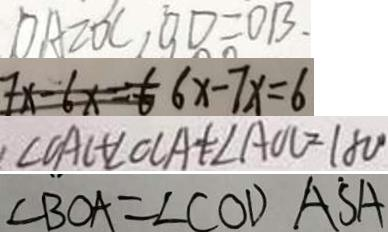Convert formula to latex. <formula><loc_0><loc_0><loc_500><loc_500>D A = O C , O D = O B . 
 7 x - 6 x = 6 6 x - 7 x = 6 
 \angle O A C + \angle O C A + \angle A O C = 1 8 0 ^ { \circ } 
 \angle B O A = \angle C O D A \dot { S } A</formula> 